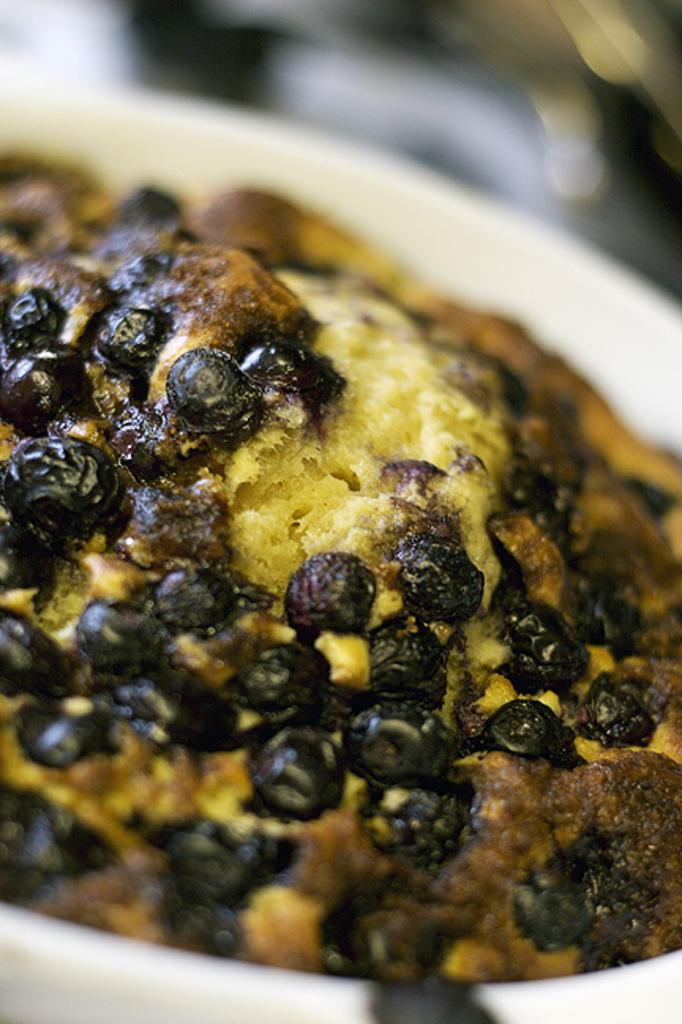What is the main subject of the image? There is a food item in a bowl in the image. Can you describe the background of the image? The background of the image is blurry. What type of van can be seen in the background of the image? There is no van present in the image; the background is blurry. What thought is the food item having in the image? Food items do not have thoughts, as they are inanimate objects. 